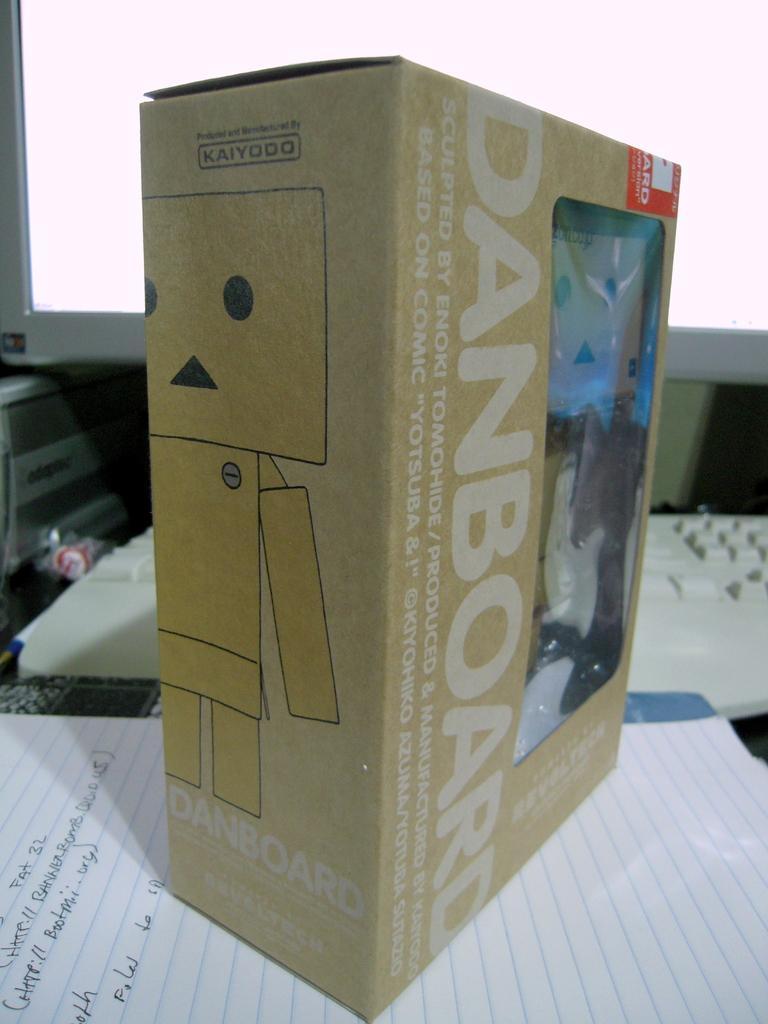Can you describe this image briefly? In this picture I can see a box, book and a paper with some text. I can see monitor and a keyboard in the background. 